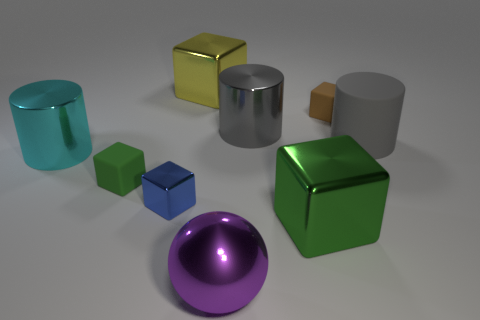Subtract all blue cubes. How many cubes are left? 4 Subtract all red cylinders. Subtract all red spheres. How many cylinders are left? 3 Add 1 large brown rubber balls. How many objects exist? 10 Subtract all balls. How many objects are left? 8 Add 9 small brown rubber blocks. How many small brown rubber blocks are left? 10 Add 6 cyan shiny cylinders. How many cyan shiny cylinders exist? 7 Subtract 0 blue spheres. How many objects are left? 9 Subtract all cyan metal cylinders. Subtract all large yellow metallic things. How many objects are left? 7 